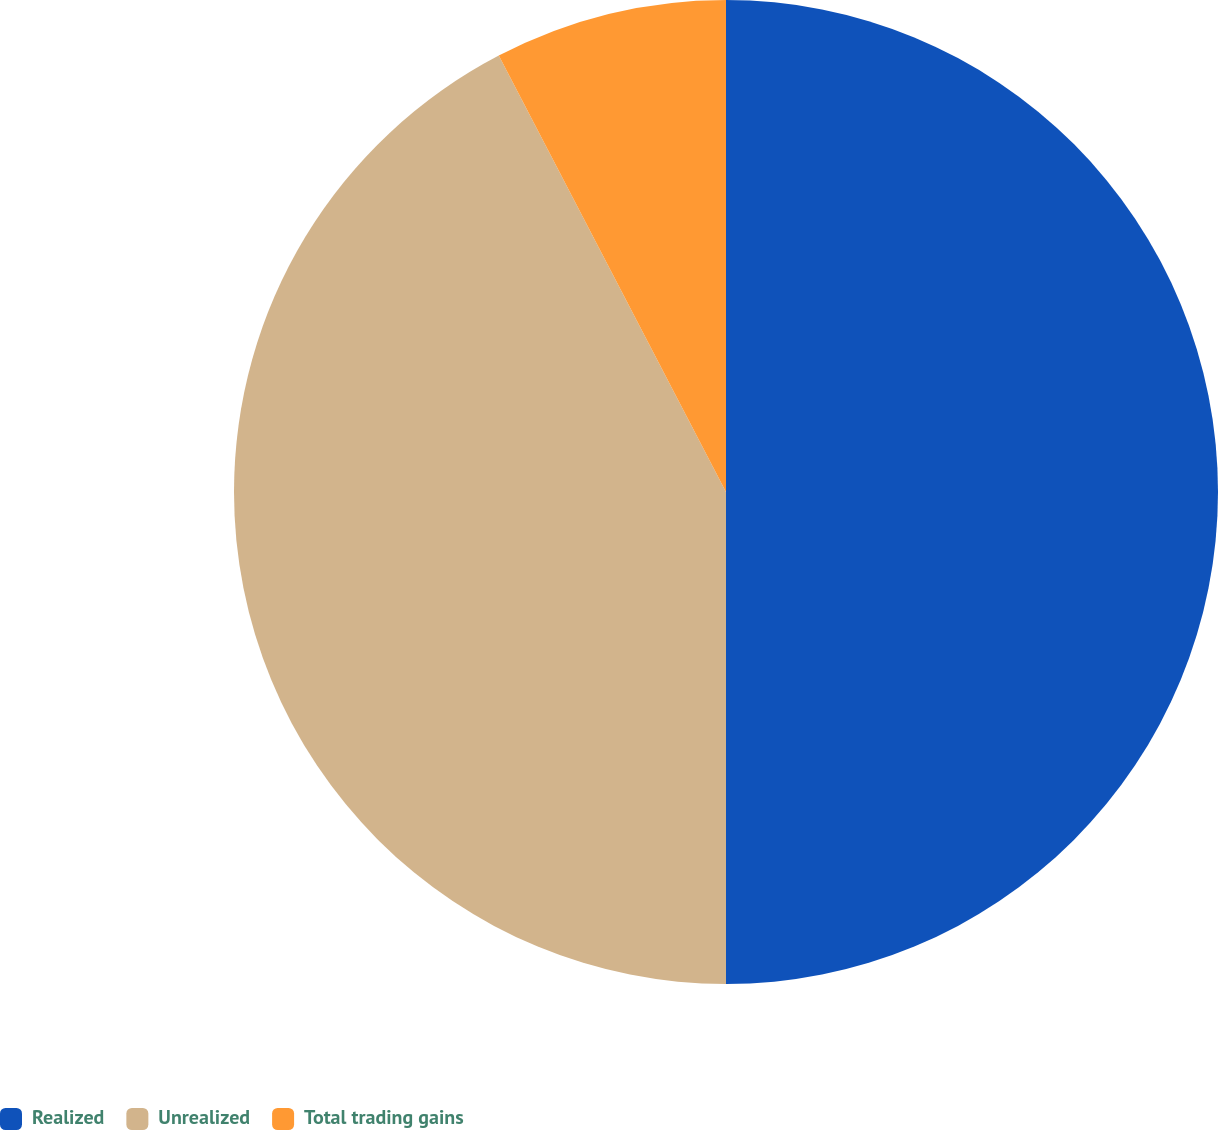Convert chart. <chart><loc_0><loc_0><loc_500><loc_500><pie_chart><fcel>Realized<fcel>Unrealized<fcel>Total trading gains<nl><fcel>50.0%<fcel>42.36%<fcel>7.64%<nl></chart> 